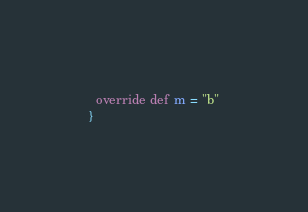Convert code to text. <code><loc_0><loc_0><loc_500><loc_500><_Scala_>  override def m = "b"
}
</code> 